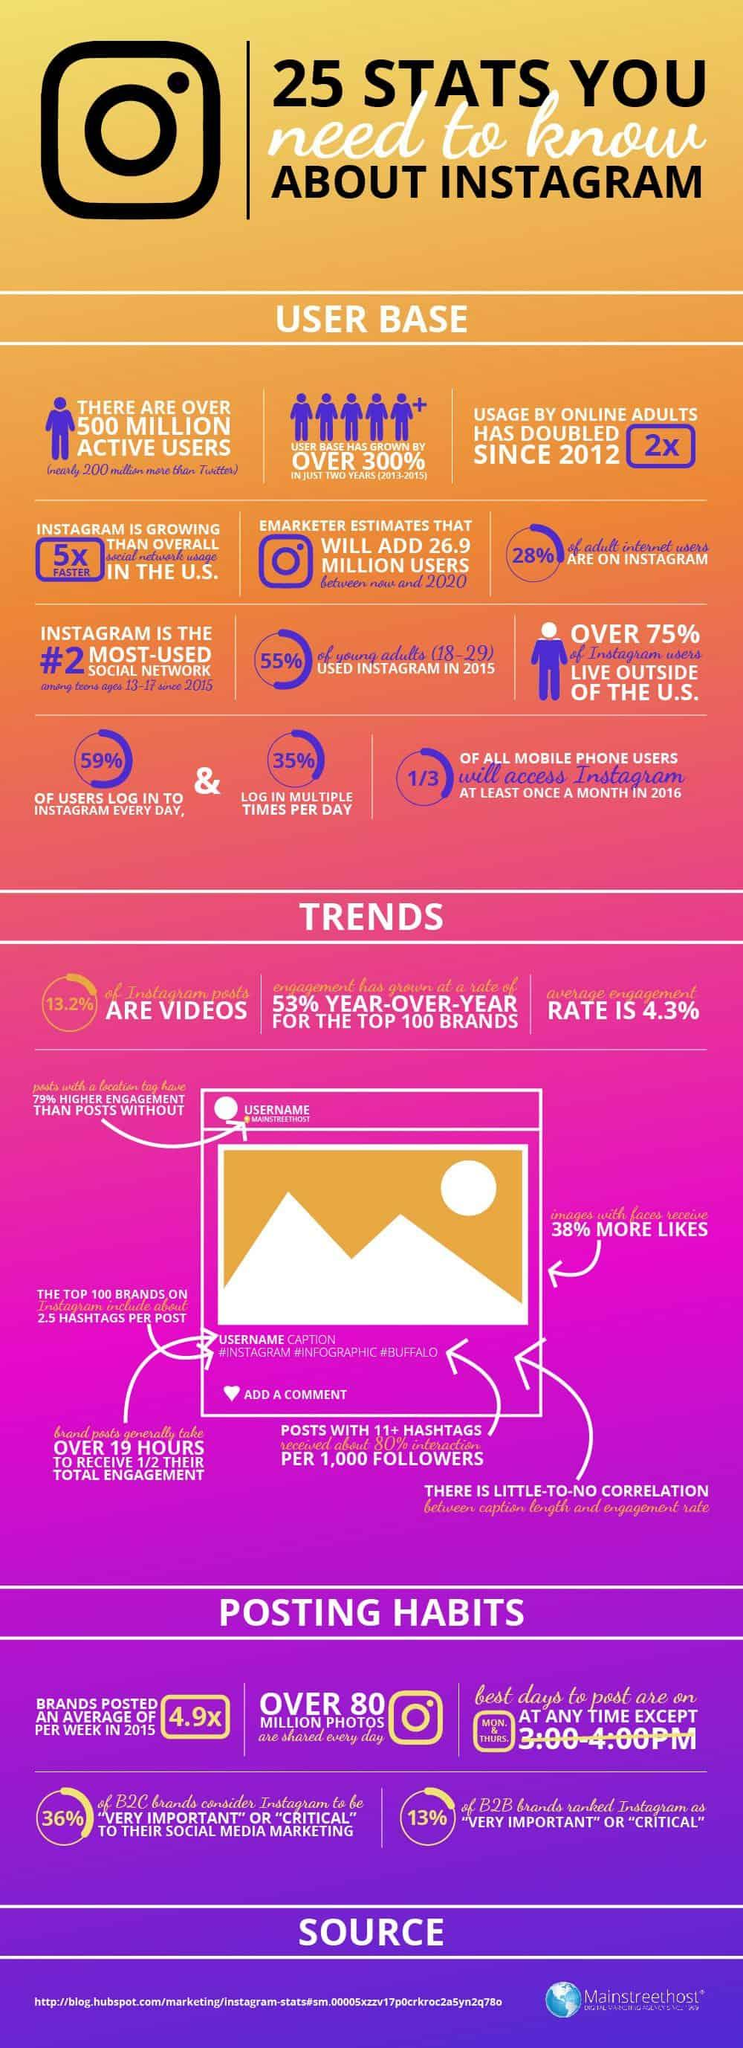Outline some significant characteristics in this image. The average engagement score on Instagram is 4.3%. According to data from 2016, approximately 67% of all smartphone users did not use Instagram on a monthly basis. The growth of Instagram users between 2013 and 2015 was over 300%, reaching more than triple the number of users in just two years. According to a study, 59% of people use Instagram on a daily basis. According to recent statistics, over 80 million photos are shared through Instagram in a single day. 